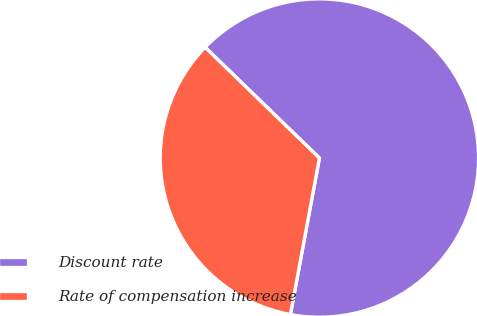Convert chart to OTSL. <chart><loc_0><loc_0><loc_500><loc_500><pie_chart><fcel>Discount rate<fcel>Rate of compensation increase<nl><fcel>65.67%<fcel>34.33%<nl></chart> 